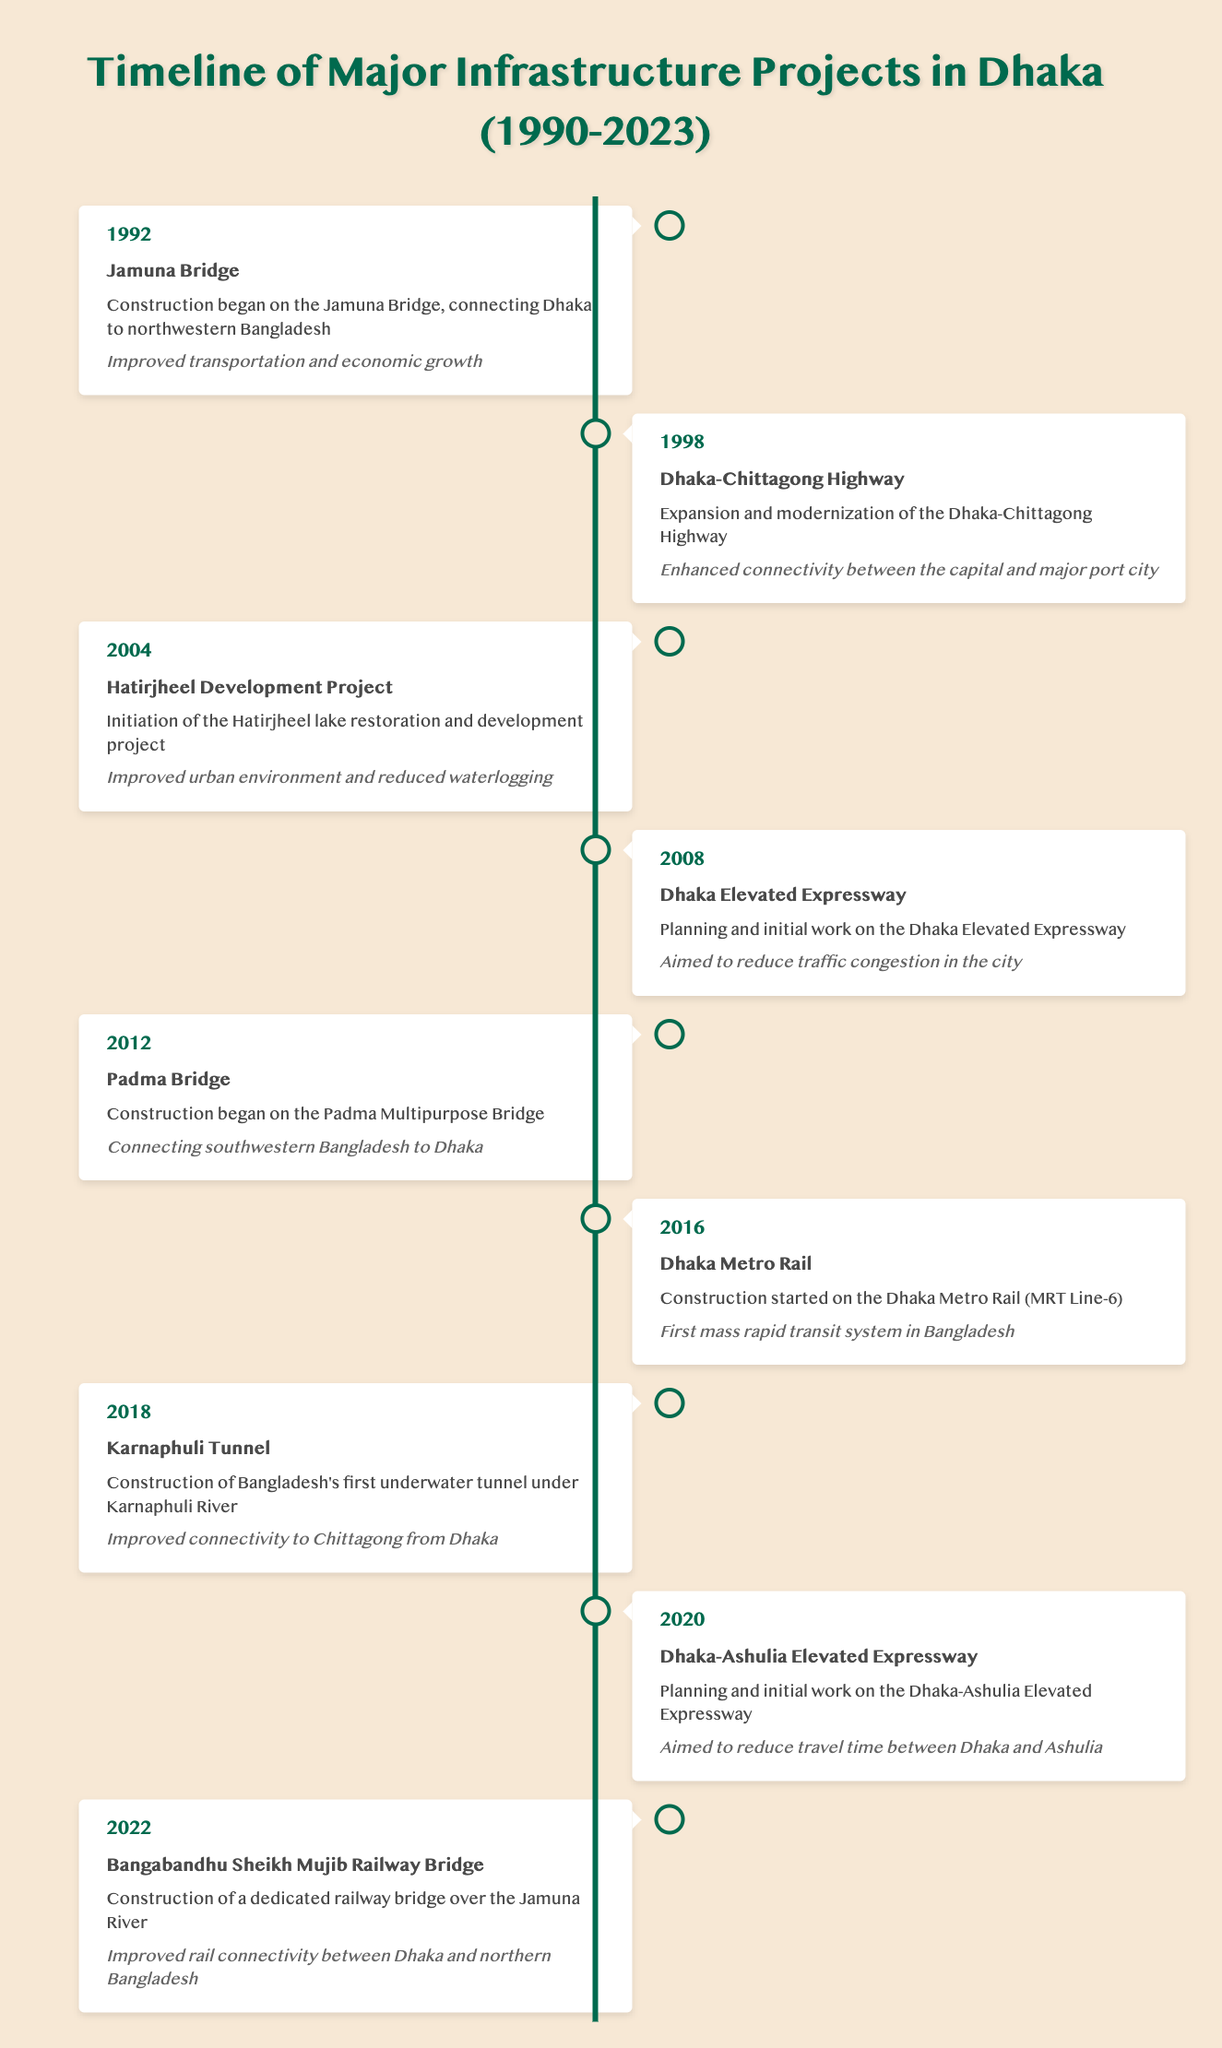What year did the construction of the Jamuna Bridge begin? According to the table, the construction of the Jamuna Bridge began in 1992. This information is found in the first row under the "year" column.
Answer: 1992 Which project aimed to reduce traffic congestion in Dhaka? The table indicates that the Dhaka Elevated Expressway, which was planned in 2008, aimed to reduce traffic congestion in the city. This is found in the corresponding project description.
Answer: Dhaka Elevated Expressway How many major infrastructure projects were initiated after 2015? From the timeline provided, the projects initiated after 2015 are the Dhaka Metro Rail (2016), Karnaphuli Tunnel (2018), Dhaka-Ashulia Elevated Expressway (2020), and Bangabandhu Sheikh Mujib Railway Bridge (2022). This totals to four projects.
Answer: 4 Did the Padma Bridge involve any construction? According to the timeline, construction on the Padma Multipurpose Bridge began in 2012, which indicates that it indeed involved construction. This can be confirmed by the entry in the timeline.
Answer: Yes What is the impact of the Karnaphuli Tunnel as described in the table? The impact of the Karnaphuli Tunnel, constructed in 2018, is stated as improved connectivity to Chittagong from Dhaka. This impact is explicitly mentioned in the project description in the timeline.
Answer: Improved connectivity to Chittagong from Dhaka Which infrastructure project was initiated the earliest, and what was its impact? Referring to the timeline, the earliest project initiated is the Jamuna Bridge in 1992, with the impact being improved transportation and economic growth. This is verified by the first entry in the table.
Answer: Jamuna Bridge; improved transportation and economic growth What year marks the start of construction for the Dhaka Metro Rail, and how many years after the Jamuna Bridge was this? The construction of the Dhaka Metro Rail started in 2016. Since the Jamuna Bridge construction began in 1992, the difference in years is 2016 - 1992 = 24 years.
Answer: 2016; 24 years How does the Dhaka-Chittagong Highway project impact connectivity? The timeline describes that the Dhaka-Chittagong Highway project enhances connectivity between the capital (Dhaka) and the major port city (Chittagong). This information is readily found in the table's entry for the highway project.
Answer: Enhanced connectivity between Dhaka and Chittagong What project is specifically mentioned to connect southwestern Bangladesh to Dhaka? The Padma Bridge project is the one specifically mentioned to connect southwestern Bangladesh to Dhaka, as noted in the 2012 entry in the table.
Answer: Padma Bridge 